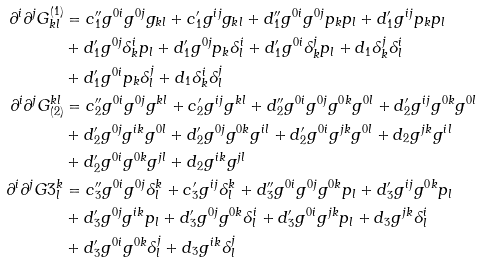Convert formula to latex. <formula><loc_0><loc_0><loc_500><loc_500>\partial ^ { i } \partial ^ { j } G ^ { ( 1 ) } _ { k l } & = c _ { 1 } ^ { \prime \prime } g ^ { 0 i } g ^ { 0 j } g _ { k l } + c _ { 1 } ^ { \prime } g ^ { i j } g _ { k l } + d _ { 1 } ^ { \prime \prime } g ^ { 0 i } g ^ { 0 j } p _ { k } p _ { l } + d _ { 1 } ^ { \prime } g ^ { i j } p _ { k } p _ { l } \\ & + d _ { 1 } ^ { \prime } g ^ { 0 j } \delta ^ { i } _ { k } p _ { l } + d _ { 1 } ^ { \prime } g ^ { 0 j } p _ { k } \delta ^ { i } _ { l } + d _ { 1 } ^ { \prime } g ^ { 0 i } \delta ^ { j } _ { k } p _ { l } + d _ { 1 } \delta ^ { j } _ { k } \delta ^ { i } _ { l } \\ & + d _ { 1 } ^ { \prime } g ^ { 0 i } p _ { k } \delta ^ { j } _ { l } + d _ { 1 } \delta ^ { i } _ { k } \delta ^ { j } _ { l } \\ \partial ^ { i } \partial ^ { j } G _ { ( 2 ) } ^ { k l } & = c _ { 2 } ^ { \prime \prime } g ^ { 0 i } g ^ { 0 j } g ^ { k l } + c _ { 2 } ^ { \prime } g ^ { i j } g ^ { k l } + d _ { 2 } ^ { \prime \prime } g ^ { 0 i } g ^ { 0 j } g ^ { 0 k } g ^ { 0 l } + d _ { 2 } ^ { \prime } g ^ { i j } g ^ { 0 k } g ^ { 0 l } \\ & + d _ { 2 } ^ { \prime } g ^ { 0 j } g ^ { i k } g ^ { 0 l } + d _ { 2 } ^ { \prime } g ^ { 0 j } g ^ { 0 k } g ^ { i l } + d _ { 2 } ^ { \prime } g ^ { 0 i } g ^ { j k } g ^ { 0 l } + d _ { 2 } g ^ { j k } g ^ { i l } \\ & + d _ { 2 } ^ { \prime } g ^ { 0 i } g ^ { 0 k } g ^ { j l } + d _ { 2 } g ^ { i k } g ^ { j l } \\ \partial ^ { i } \partial ^ { j } G 3 ^ { k } _ { l } & = c _ { 3 } ^ { \prime \prime } g ^ { 0 i } g ^ { 0 j } \delta ^ { k } _ { l } + c _ { 3 } ^ { \prime } g ^ { i j } \delta ^ { k } _ { l } + d _ { 3 } ^ { \prime \prime } g ^ { 0 i } g ^ { 0 j } g ^ { 0 k } p _ { l } + d _ { 3 } ^ { \prime } g ^ { i j } g ^ { 0 k } p _ { l } \\ & + d _ { 3 } ^ { \prime } g ^ { 0 j } g ^ { i k } p _ { l } + d _ { 3 } ^ { \prime } g ^ { 0 j } g ^ { 0 k } \delta ^ { i } _ { l } + d _ { 3 } ^ { \prime } g ^ { 0 i } g ^ { j k } p _ { l } + d _ { 3 } g ^ { j k } \delta ^ { i } _ { l } \\ & + d _ { 3 } ^ { \prime } g ^ { 0 i } g ^ { 0 k } \delta ^ { j } _ { l } + d _ { 3 } g ^ { i k } \delta ^ { j } _ { l }</formula> 